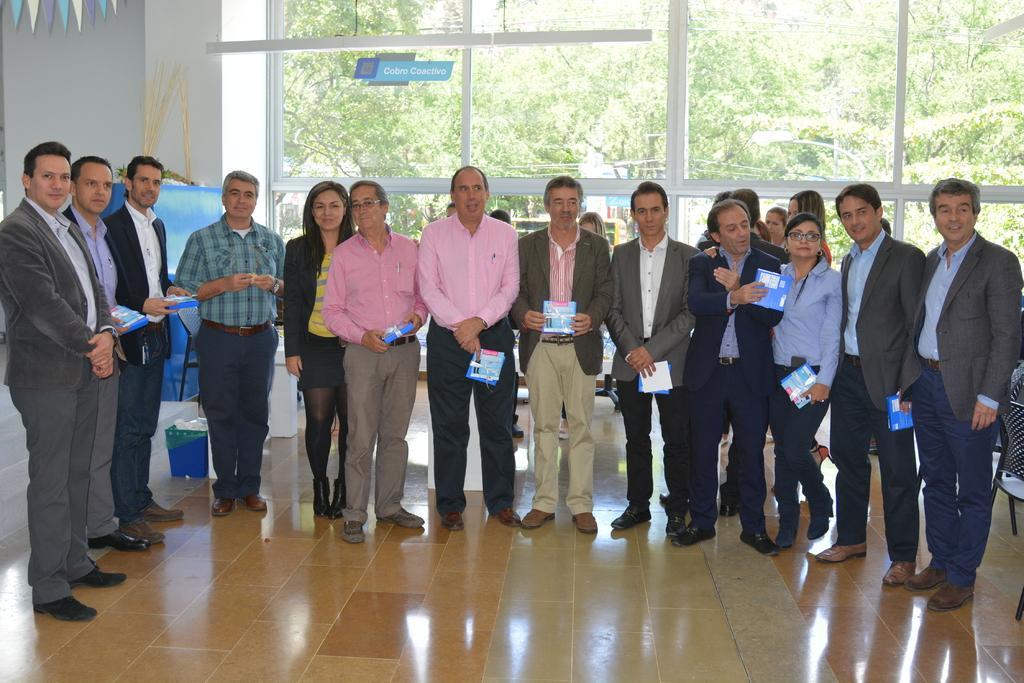Please provide a concise description of this image. There are few people here standing on the floor and few are holding books in their hands. In the background there is a decorative item on the left,chairs,sticker on the glass and some other items. Through the glass door we can see trees and a vehicle. 